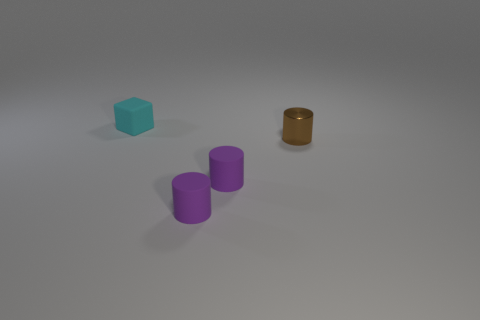What is the color of the block?
Offer a terse response. Cyan. How many objects are objects behind the brown metallic thing or brown rubber blocks?
Your answer should be compact. 1. Is there anything else that has the same material as the cyan block?
Your answer should be very brief. Yes. What number of things are either tiny cylinders that are on the left side of the brown metal thing or brown cylinders that are right of the rubber block?
Make the answer very short. 3. Is the brown object made of the same material as the object behind the tiny metal thing?
Make the answer very short. No. How many other objects are there of the same color as the small matte cube?
Ensure brevity in your answer.  0. The metallic thing has what shape?
Ensure brevity in your answer.  Cylinder. Do the metal cylinder and the small matte object that is behind the small brown cylinder have the same color?
Your answer should be compact. No. Is there a purple cylinder that has the same size as the cyan rubber object?
Ensure brevity in your answer.  Yes. What material is the cyan thing that is the same size as the brown cylinder?
Your answer should be very brief. Rubber. 